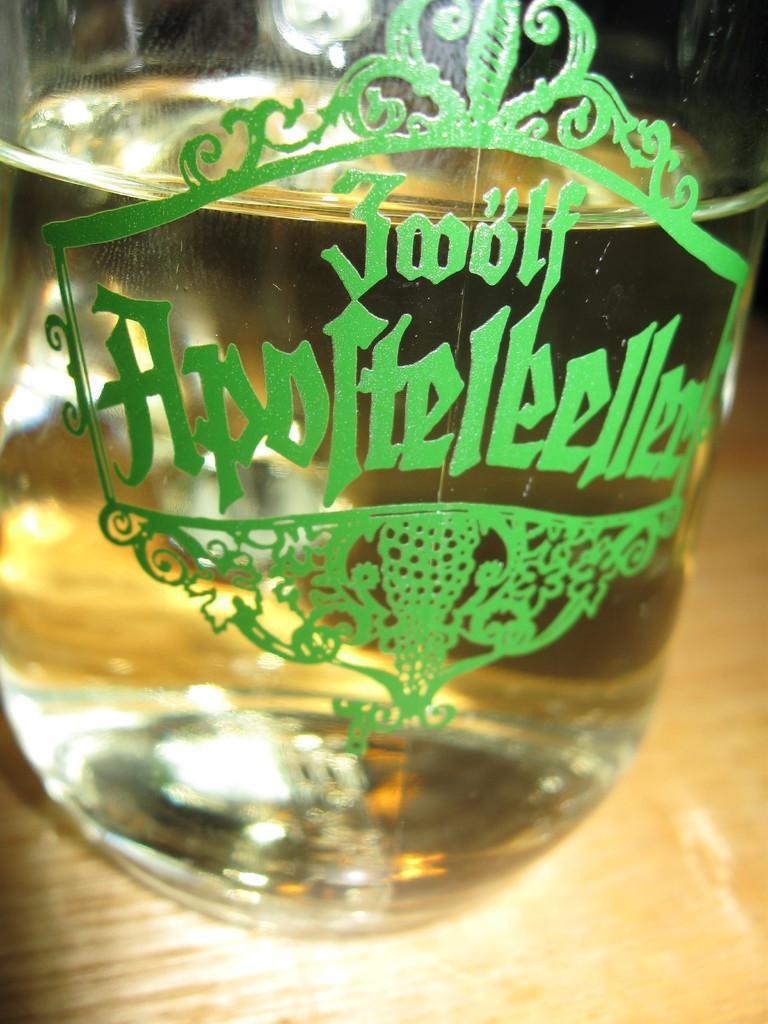Please provide a concise description of this image. In this picture we can see a glass in which we can see liquid. 